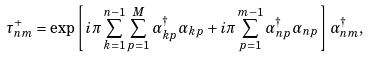Convert formula to latex. <formula><loc_0><loc_0><loc_500><loc_500>\tau ^ { + } _ { n m } = \exp \left [ i \pi \sum ^ { n - 1 } _ { k = 1 } \sum ^ { M } _ { p = 1 } \alpha ^ { \dag } _ { k p } \alpha _ { k p } + i \pi \sum ^ { m - 1 } _ { p = 1 } \alpha ^ { \dag } _ { n p } \alpha _ { n p } \right ] \alpha ^ { \dag } _ { n m } ,</formula> 